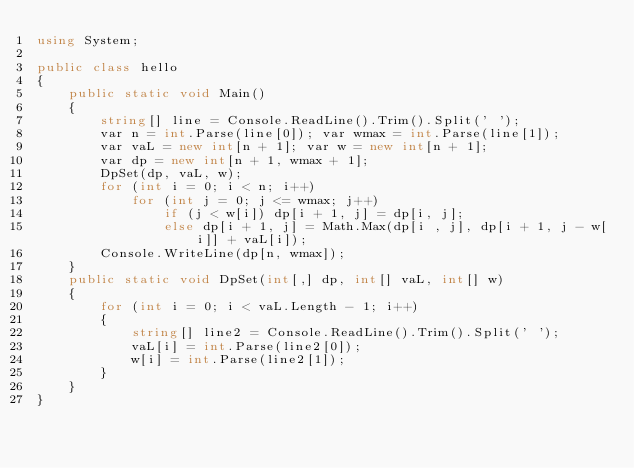Convert code to text. <code><loc_0><loc_0><loc_500><loc_500><_C#_>using System;

public class hello
{
    public static void Main()
    {
        string[] line = Console.ReadLine().Trim().Split(' ');
        var n = int.Parse(line[0]); var wmax = int.Parse(line[1]);
        var vaL = new int[n + 1]; var w = new int[n + 1];
        var dp = new int[n + 1, wmax + 1];
        DpSet(dp, vaL, w);
        for (int i = 0; i < n; i++)
            for (int j = 0; j <= wmax; j++)
                if (j < w[i]) dp[i + 1, j] = dp[i, j];
                else dp[i + 1, j] = Math.Max(dp[i , j], dp[i + 1, j - w[i]] + vaL[i]);
        Console.WriteLine(dp[n, wmax]);
    }
    public static void DpSet(int[,] dp, int[] vaL, int[] w)
    {
        for (int i = 0; i < vaL.Length - 1; i++)
        {
            string[] line2 = Console.ReadLine().Trim().Split(' ');
            vaL[i] = int.Parse(line2[0]);
            w[i] = int.Parse(line2[1]);
        }
    }
}</code> 